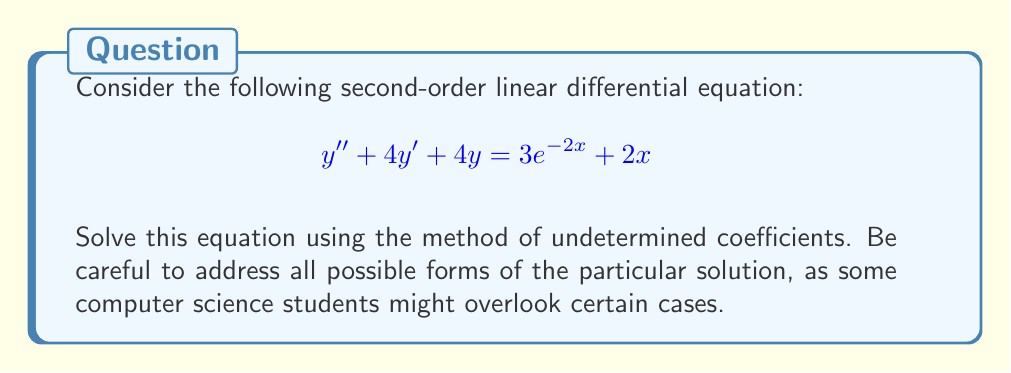Provide a solution to this math problem. Let's solve this step-by-step using the method of undetermined coefficients:

1) The general solution will be of the form $y = y_c + y_p$, where $y_c$ is the complementary solution and $y_p$ is the particular solution.

2) First, let's find $y_c$. The characteristic equation is:
   $$r^2 + 4r + 4 = 0$$
   $$(r + 2)^2 = 0$$
   $$r = -2 \text{ (repeated root)}$$

   Therefore, $y_c = c_1e^{-2x} + c_2xe^{-2x}$

3) Now, let's find $y_p$. We need to consider both $3e^{-2x}$ and $2x$ terms:

   a) For $3e^{-2x}$:
      Since $e^{-2x}$ is already in $y_c$, we need to multiply our guess by $x$:
      $y_{p1} = Axe^{-2x}$

   b) For $2x$:
      We can use the form $y_{p2} = Bx + C$

   So, our complete guess for $y_p$ is:
   $$y_p = Axe^{-2x} + Bx + C$$

4) Substitute this into the original equation:
   $$(Axe^{-2x} + Bx + C)'' + 4(Axe^{-2x} + Bx + C)' + 4(Axe^{-2x} + Bx + C) = 3e^{-2x} + 2x$$

5) Differentiate and simplify:
   $$(-4Axe^{-2x} - 2Ae^{-2x} + B) + 4(-2Axe^{-2x} + Ae^{-2x} + B) + 4(Axe^{-2x} + Bx + C) = 3e^{-2x} + 2x$$

6) Collect like terms:
   $$3Ae^{-2x} + 4Bx + (4C + B) = 3e^{-2x} + 2x$$

7) Equate coefficients:
   $$3A = 3$$
   $$4B = 2$$
   $$4C + B = 0$$

8) Solve for A, B, and C:
   $$A = 1$$
   $$B = \frac{1}{2}$$
   $$C = -\frac{1}{8}$$

9) Therefore, the particular solution is:
   $$y_p = xe^{-2x} + \frac{1}{2}x - \frac{1}{8}$$

10) The general solution is:
    $$y = y_c + y_p = c_1e^{-2x} + c_2xe^{-2x} + xe^{-2x} + \frac{1}{2}x - \frac{1}{8}$$
Answer: $$y = c_1e^{-2x} + c_2xe^{-2x} + xe^{-2x} + \frac{1}{2}x - \frac{1}{8}$$ 